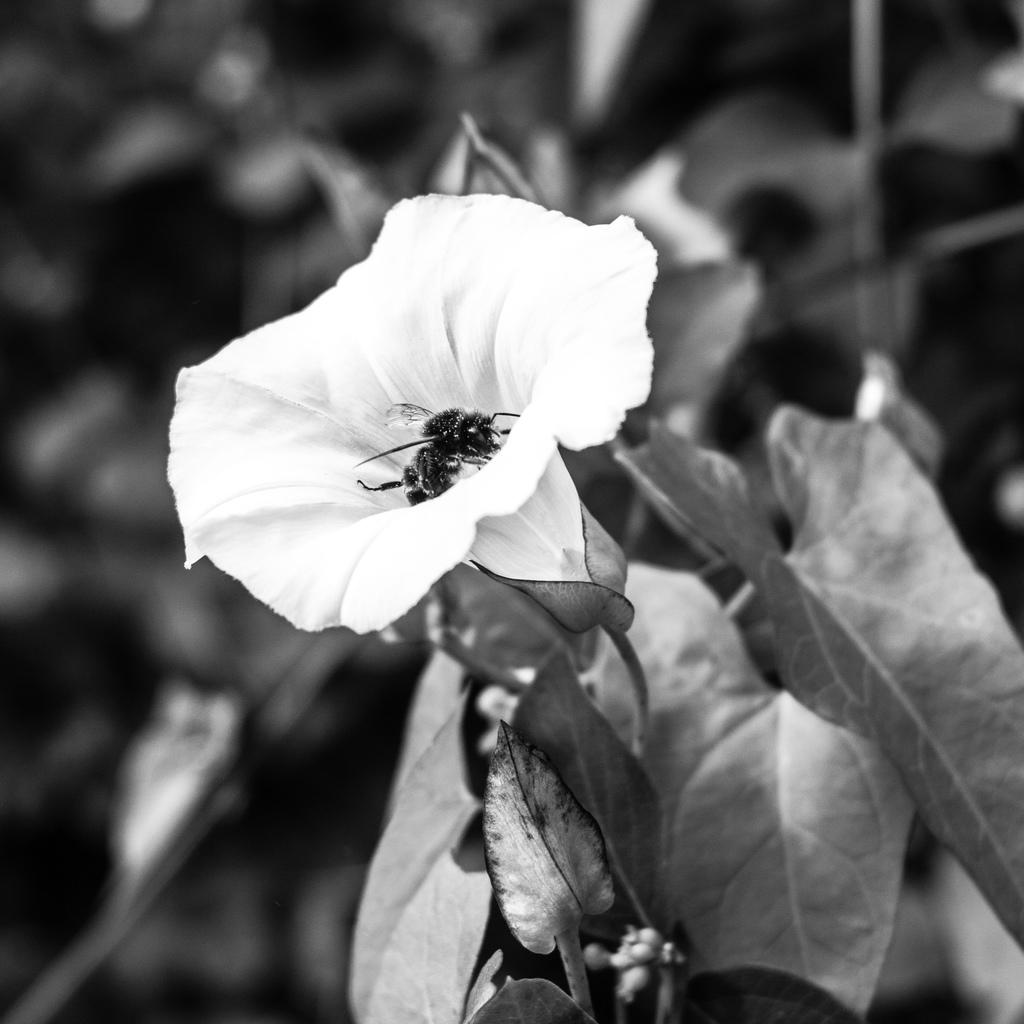What is the color scheme of the image? The image is black and white. Can you describe the background of the image? The background of the image is blurred. What type of plant can be seen in the image? There is a flower in the image. What else is present in the image besides the flower? There are leaves in the image. What type of spark can be seen coming from the dolls in the image? There are no dolls present in the image, and therefore no sparks can be seen. What type of amusement can be seen in the image? There is no amusement depicted in the image; it features a flower and leaves. 